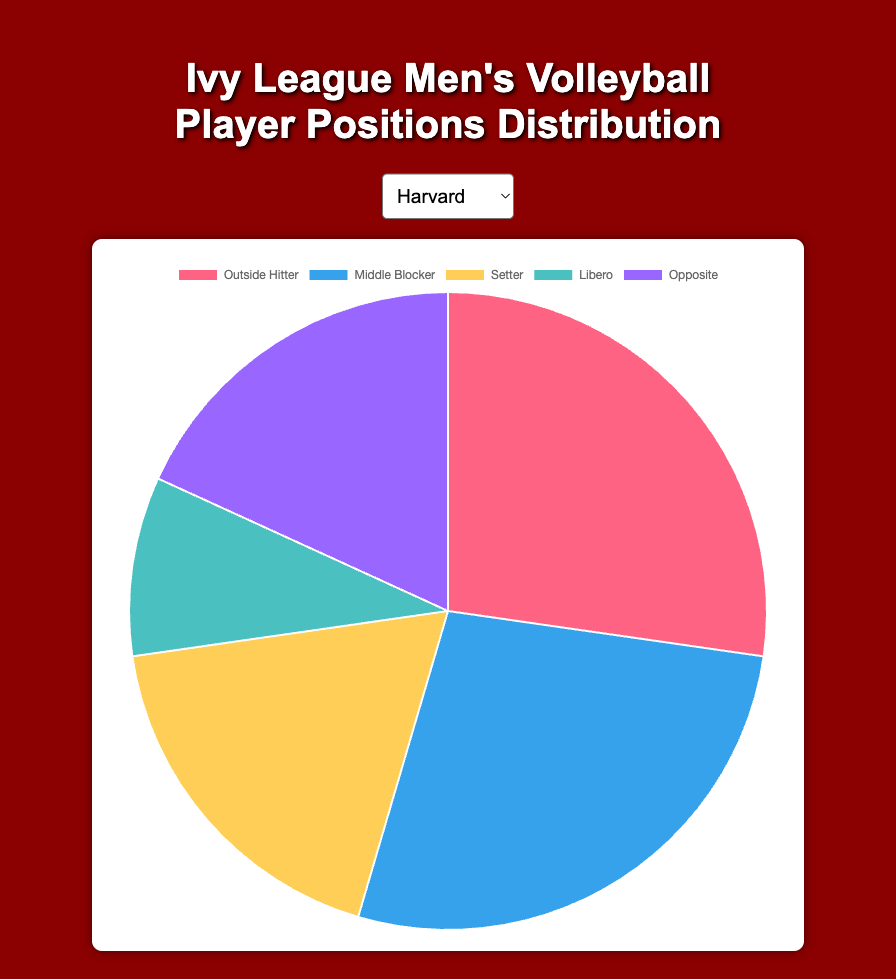What is the percentage of Outside Hitters in the Harvard Men's Volleyball team? First, identify the number of Outside Hitters in the Harvard team, which is 3. Next, sum all players in the Harvard team: 3 (Outside Hitter) + 3 (Middle Blocker) + 2 (Setter) + 1 (Libero) + 2 (Opposite) = 11. The percentage is then calculated as (3/11) * 100 ≈ 27.27%.
Answer: 27.27% How does the number of Middle Blockers in Harvard compare with that in Yale? Harvard has 3 Middle Blockers, while Yale has 2 Middle Blockers. Compare these two numbers. Harvard has one more Middle Blocker than Yale.
Answer: Harvard has 1 more What is the most common position in the Columbia Men's Volleyball team? By looking at the distribution, Columbia has the most players in the Outside Hitter position with a tally of 4, which is higher than any other individual position in the team.
Answer: Outside Hitter If you sum the number of Setters and Liberos in the Princeton Men's Volleyball team, what is the result? Princeton has 2 Setters and 1 Libero. Summing these gives 2 + 1 = 3.
Answer: 3 What position has the smallest representation in the Penn Men's Volleyball team, and what percentage do they make up? Penn has only 1 Libero, which is the smallest number for any position in the team. The total players in Penn is 3 (Outside Hitter) + 3 (Middle Blocker) + 2 (Setter) + 1 (Libero) + 2 (Opposite) = 11. The percentage is (1/11) * 100 ≈ 9.09%.
Answer: Libero, 9.09% Compare the total number of players in the Yale and Cornell teams. Which team has more players? For both Yale and Cornell, the total can be calculated as follows:
Yale: 4 (Outside Hitter) + 2 (Middle Blocker) + 2 (Setter) + 1 (Libero) + 2 (Opposite) = 11
Cornell: 3 (Outside Hitter) + 3 (Middle Blocker) + 2 (Setter) + 1 (Libero) + 2 (Opposite) = 11
Both teams have the same number of players.
Answer: Both have the same number What's the difference between the number of Outside Hitters in Brown and Princeton? Brown has 4 Outside Hitters while Princeton has 3. The difference is 4 - 3 = 1.
Answer: 1 How many teams have exactly 3 Middle Blockers, and can you name them? By looking at the data, teams with 3 Middle Blockers are Harvard, Princeton, Cornell, and Penn. Count these teams and identify them.
Answer: 4 teams: Harvard, Princeton, Cornell, Penn 